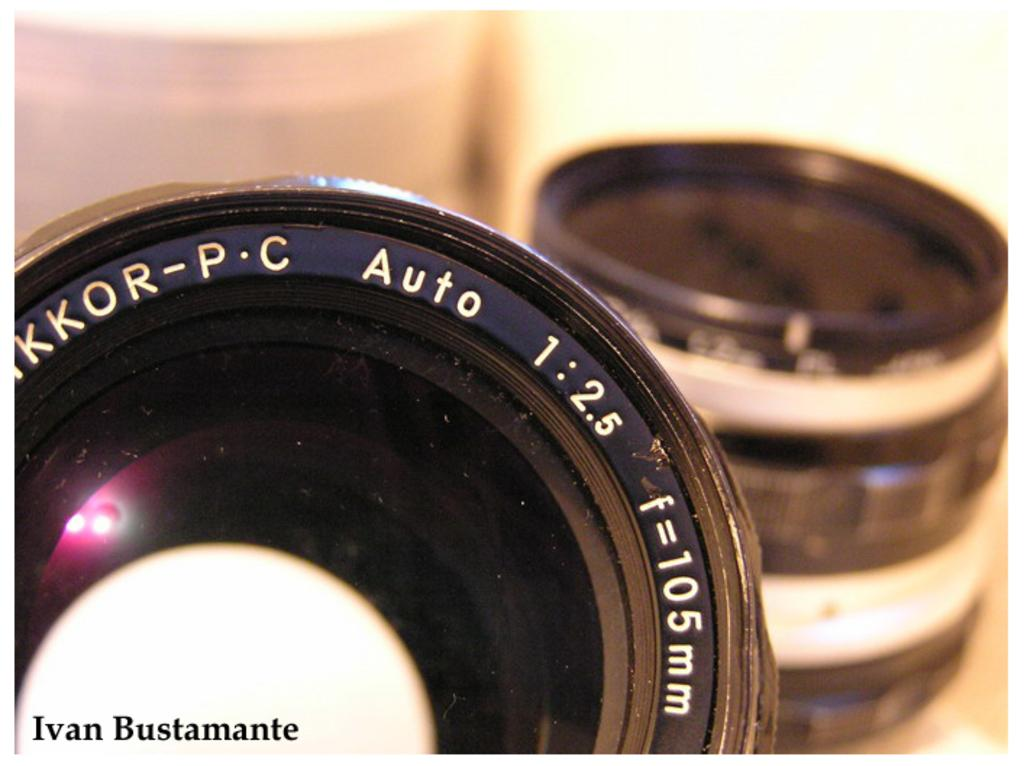What is the main subject of the image? The main subject of the image is a camera lens. Can you describe any additional features or elements in the image? Yes, there is a watermark on the left side bottom of the image. How would you describe the background of the image? The background of the image is blurred. What type of rifle is depicted in the image? There is no rifle present in the image; it features a camera lens and a watermark. What riddle can be solved by looking at the image? There is no riddle associated with the image; it simply shows a camera lens and a watermark. 